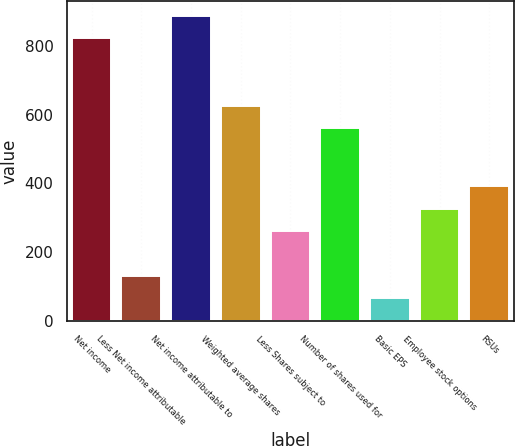<chart> <loc_0><loc_0><loc_500><loc_500><bar_chart><fcel>Net income<fcel>Less Net income attributable<fcel>Net income attributable to<fcel>Weighted average shares<fcel>Less Shares subject to<fcel>Number of shares used for<fcel>Basic EPS<fcel>Employee stock options<fcel>RSUs<nl><fcel>821.36<fcel>131.28<fcel>886.45<fcel>626.09<fcel>261.46<fcel>561<fcel>66.19<fcel>326.55<fcel>391.64<nl></chart> 